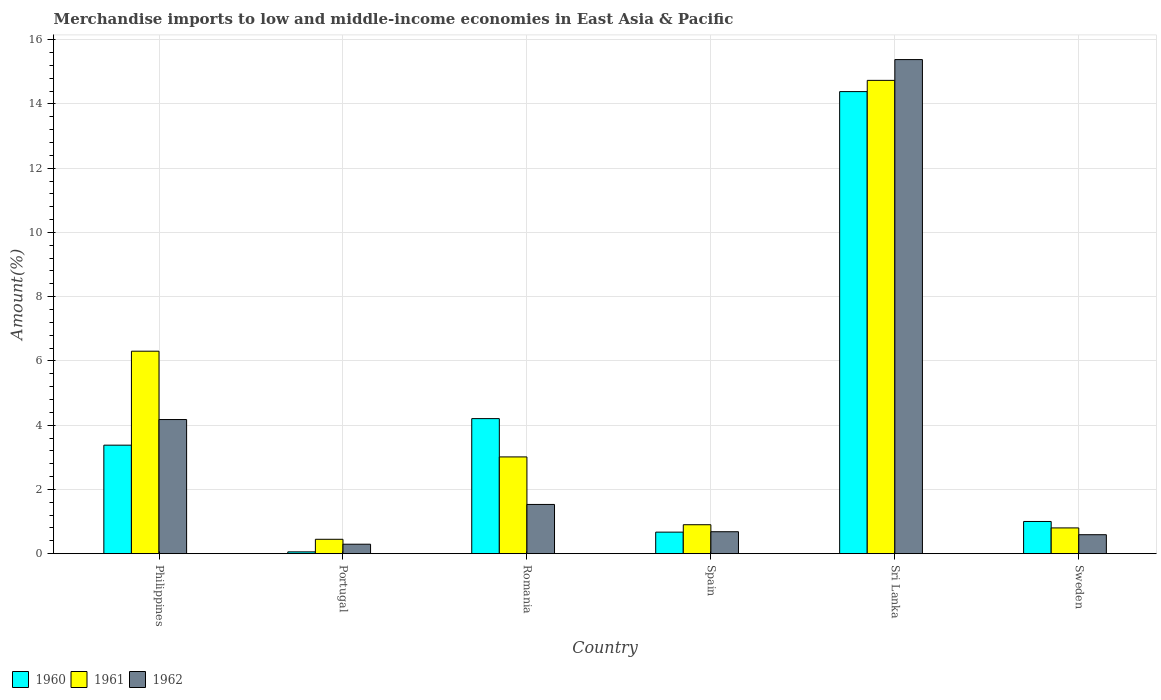How many groups of bars are there?
Provide a short and direct response. 6. Are the number of bars per tick equal to the number of legend labels?
Your answer should be compact. Yes. Are the number of bars on each tick of the X-axis equal?
Provide a short and direct response. Yes. How many bars are there on the 3rd tick from the right?
Your answer should be very brief. 3. What is the percentage of amount earned from merchandise imports in 1960 in Philippines?
Offer a terse response. 3.38. Across all countries, what is the maximum percentage of amount earned from merchandise imports in 1960?
Keep it short and to the point. 14.38. Across all countries, what is the minimum percentage of amount earned from merchandise imports in 1962?
Give a very brief answer. 0.29. In which country was the percentage of amount earned from merchandise imports in 1962 maximum?
Offer a very short reply. Sri Lanka. What is the total percentage of amount earned from merchandise imports in 1961 in the graph?
Keep it short and to the point. 26.2. What is the difference between the percentage of amount earned from merchandise imports in 1961 in Spain and that in Sweden?
Provide a succinct answer. 0.1. What is the difference between the percentage of amount earned from merchandise imports in 1960 in Sri Lanka and the percentage of amount earned from merchandise imports in 1962 in Philippines?
Make the answer very short. 10.21. What is the average percentage of amount earned from merchandise imports in 1960 per country?
Offer a terse response. 3.95. What is the difference between the percentage of amount earned from merchandise imports of/in 1961 and percentage of amount earned from merchandise imports of/in 1962 in Philippines?
Keep it short and to the point. 2.13. What is the ratio of the percentage of amount earned from merchandise imports in 1962 in Philippines to that in Portugal?
Ensure brevity in your answer.  14.2. Is the percentage of amount earned from merchandise imports in 1961 in Spain less than that in Sweden?
Provide a short and direct response. No. Is the difference between the percentage of amount earned from merchandise imports in 1961 in Romania and Sweden greater than the difference between the percentage of amount earned from merchandise imports in 1962 in Romania and Sweden?
Your response must be concise. Yes. What is the difference between the highest and the second highest percentage of amount earned from merchandise imports in 1960?
Offer a very short reply. -0.83. What is the difference between the highest and the lowest percentage of amount earned from merchandise imports in 1962?
Make the answer very short. 15.09. In how many countries, is the percentage of amount earned from merchandise imports in 1962 greater than the average percentage of amount earned from merchandise imports in 1962 taken over all countries?
Offer a terse response. 2. Is the sum of the percentage of amount earned from merchandise imports in 1962 in Romania and Sri Lanka greater than the maximum percentage of amount earned from merchandise imports in 1961 across all countries?
Give a very brief answer. Yes. What does the 3rd bar from the left in Sri Lanka represents?
Offer a very short reply. 1962. Is it the case that in every country, the sum of the percentage of amount earned from merchandise imports in 1961 and percentage of amount earned from merchandise imports in 1962 is greater than the percentage of amount earned from merchandise imports in 1960?
Your answer should be very brief. Yes. Are the values on the major ticks of Y-axis written in scientific E-notation?
Offer a very short reply. No. Does the graph contain any zero values?
Give a very brief answer. No. Where does the legend appear in the graph?
Your response must be concise. Bottom left. How many legend labels are there?
Offer a very short reply. 3. How are the legend labels stacked?
Your answer should be very brief. Horizontal. What is the title of the graph?
Your answer should be very brief. Merchandise imports to low and middle-income economies in East Asia & Pacific. Does "1979" appear as one of the legend labels in the graph?
Offer a very short reply. No. What is the label or title of the X-axis?
Give a very brief answer. Country. What is the label or title of the Y-axis?
Your answer should be very brief. Amount(%). What is the Amount(%) in 1960 in Philippines?
Ensure brevity in your answer.  3.38. What is the Amount(%) in 1961 in Philippines?
Keep it short and to the point. 6.3. What is the Amount(%) in 1962 in Philippines?
Your answer should be very brief. 4.18. What is the Amount(%) in 1960 in Portugal?
Offer a terse response. 0.06. What is the Amount(%) of 1961 in Portugal?
Offer a very short reply. 0.45. What is the Amount(%) in 1962 in Portugal?
Your answer should be compact. 0.29. What is the Amount(%) in 1960 in Romania?
Offer a very short reply. 4.2. What is the Amount(%) in 1961 in Romania?
Your answer should be compact. 3.01. What is the Amount(%) of 1962 in Romania?
Provide a short and direct response. 1.53. What is the Amount(%) in 1960 in Spain?
Keep it short and to the point. 0.67. What is the Amount(%) in 1961 in Spain?
Offer a very short reply. 0.9. What is the Amount(%) in 1962 in Spain?
Offer a very short reply. 0.68. What is the Amount(%) of 1960 in Sri Lanka?
Offer a very short reply. 14.38. What is the Amount(%) of 1961 in Sri Lanka?
Provide a succinct answer. 14.73. What is the Amount(%) in 1962 in Sri Lanka?
Keep it short and to the point. 15.38. What is the Amount(%) of 1960 in Sweden?
Offer a very short reply. 1. What is the Amount(%) in 1961 in Sweden?
Your answer should be compact. 0.8. What is the Amount(%) in 1962 in Sweden?
Provide a succinct answer. 0.59. Across all countries, what is the maximum Amount(%) in 1960?
Keep it short and to the point. 14.38. Across all countries, what is the maximum Amount(%) of 1961?
Offer a terse response. 14.73. Across all countries, what is the maximum Amount(%) of 1962?
Make the answer very short. 15.38. Across all countries, what is the minimum Amount(%) of 1960?
Offer a very short reply. 0.06. Across all countries, what is the minimum Amount(%) in 1961?
Provide a short and direct response. 0.45. Across all countries, what is the minimum Amount(%) of 1962?
Ensure brevity in your answer.  0.29. What is the total Amount(%) in 1960 in the graph?
Make the answer very short. 23.69. What is the total Amount(%) in 1961 in the graph?
Keep it short and to the point. 26.2. What is the total Amount(%) in 1962 in the graph?
Offer a terse response. 22.65. What is the difference between the Amount(%) of 1960 in Philippines and that in Portugal?
Ensure brevity in your answer.  3.32. What is the difference between the Amount(%) of 1961 in Philippines and that in Portugal?
Make the answer very short. 5.86. What is the difference between the Amount(%) of 1962 in Philippines and that in Portugal?
Ensure brevity in your answer.  3.88. What is the difference between the Amount(%) in 1960 in Philippines and that in Romania?
Your response must be concise. -0.83. What is the difference between the Amount(%) in 1961 in Philippines and that in Romania?
Your response must be concise. 3.29. What is the difference between the Amount(%) in 1962 in Philippines and that in Romania?
Keep it short and to the point. 2.64. What is the difference between the Amount(%) of 1960 in Philippines and that in Spain?
Ensure brevity in your answer.  2.71. What is the difference between the Amount(%) of 1961 in Philippines and that in Spain?
Your response must be concise. 5.4. What is the difference between the Amount(%) of 1962 in Philippines and that in Spain?
Provide a succinct answer. 3.49. What is the difference between the Amount(%) of 1960 in Philippines and that in Sri Lanka?
Make the answer very short. -11.01. What is the difference between the Amount(%) in 1961 in Philippines and that in Sri Lanka?
Offer a terse response. -8.43. What is the difference between the Amount(%) of 1962 in Philippines and that in Sri Lanka?
Your answer should be compact. -11.21. What is the difference between the Amount(%) in 1960 in Philippines and that in Sweden?
Keep it short and to the point. 2.38. What is the difference between the Amount(%) of 1961 in Philippines and that in Sweden?
Give a very brief answer. 5.5. What is the difference between the Amount(%) of 1962 in Philippines and that in Sweden?
Offer a very short reply. 3.58. What is the difference between the Amount(%) of 1960 in Portugal and that in Romania?
Your answer should be compact. -4.15. What is the difference between the Amount(%) in 1961 in Portugal and that in Romania?
Your answer should be very brief. -2.56. What is the difference between the Amount(%) in 1962 in Portugal and that in Romania?
Provide a succinct answer. -1.24. What is the difference between the Amount(%) in 1960 in Portugal and that in Spain?
Offer a terse response. -0.61. What is the difference between the Amount(%) of 1961 in Portugal and that in Spain?
Give a very brief answer. -0.45. What is the difference between the Amount(%) of 1962 in Portugal and that in Spain?
Offer a very short reply. -0.39. What is the difference between the Amount(%) of 1960 in Portugal and that in Sri Lanka?
Make the answer very short. -14.33. What is the difference between the Amount(%) in 1961 in Portugal and that in Sri Lanka?
Keep it short and to the point. -14.29. What is the difference between the Amount(%) in 1962 in Portugal and that in Sri Lanka?
Make the answer very short. -15.09. What is the difference between the Amount(%) of 1960 in Portugal and that in Sweden?
Your answer should be very brief. -0.95. What is the difference between the Amount(%) of 1961 in Portugal and that in Sweden?
Provide a succinct answer. -0.35. What is the difference between the Amount(%) of 1962 in Portugal and that in Sweden?
Provide a short and direct response. -0.3. What is the difference between the Amount(%) of 1960 in Romania and that in Spain?
Your answer should be very brief. 3.53. What is the difference between the Amount(%) in 1961 in Romania and that in Spain?
Keep it short and to the point. 2.11. What is the difference between the Amount(%) in 1962 in Romania and that in Spain?
Give a very brief answer. 0.85. What is the difference between the Amount(%) in 1960 in Romania and that in Sri Lanka?
Offer a terse response. -10.18. What is the difference between the Amount(%) of 1961 in Romania and that in Sri Lanka?
Your answer should be compact. -11.72. What is the difference between the Amount(%) of 1962 in Romania and that in Sri Lanka?
Provide a succinct answer. -13.85. What is the difference between the Amount(%) in 1960 in Romania and that in Sweden?
Give a very brief answer. 3.2. What is the difference between the Amount(%) of 1961 in Romania and that in Sweden?
Give a very brief answer. 2.21. What is the difference between the Amount(%) in 1962 in Romania and that in Sweden?
Provide a succinct answer. 0.94. What is the difference between the Amount(%) in 1960 in Spain and that in Sri Lanka?
Keep it short and to the point. -13.71. What is the difference between the Amount(%) in 1961 in Spain and that in Sri Lanka?
Provide a short and direct response. -13.83. What is the difference between the Amount(%) of 1962 in Spain and that in Sri Lanka?
Your response must be concise. -14.7. What is the difference between the Amount(%) in 1960 in Spain and that in Sweden?
Your answer should be very brief. -0.33. What is the difference between the Amount(%) in 1961 in Spain and that in Sweden?
Your response must be concise. 0.1. What is the difference between the Amount(%) of 1962 in Spain and that in Sweden?
Your answer should be very brief. 0.09. What is the difference between the Amount(%) of 1960 in Sri Lanka and that in Sweden?
Make the answer very short. 13.38. What is the difference between the Amount(%) of 1961 in Sri Lanka and that in Sweden?
Give a very brief answer. 13.93. What is the difference between the Amount(%) of 1962 in Sri Lanka and that in Sweden?
Provide a succinct answer. 14.79. What is the difference between the Amount(%) of 1960 in Philippines and the Amount(%) of 1961 in Portugal?
Offer a terse response. 2.93. What is the difference between the Amount(%) of 1960 in Philippines and the Amount(%) of 1962 in Portugal?
Your response must be concise. 3.08. What is the difference between the Amount(%) of 1961 in Philippines and the Amount(%) of 1962 in Portugal?
Give a very brief answer. 6.01. What is the difference between the Amount(%) in 1960 in Philippines and the Amount(%) in 1961 in Romania?
Provide a short and direct response. 0.37. What is the difference between the Amount(%) in 1960 in Philippines and the Amount(%) in 1962 in Romania?
Give a very brief answer. 1.85. What is the difference between the Amount(%) in 1961 in Philippines and the Amount(%) in 1962 in Romania?
Keep it short and to the point. 4.77. What is the difference between the Amount(%) of 1960 in Philippines and the Amount(%) of 1961 in Spain?
Keep it short and to the point. 2.48. What is the difference between the Amount(%) in 1960 in Philippines and the Amount(%) in 1962 in Spain?
Your answer should be compact. 2.69. What is the difference between the Amount(%) in 1961 in Philippines and the Amount(%) in 1962 in Spain?
Offer a terse response. 5.62. What is the difference between the Amount(%) in 1960 in Philippines and the Amount(%) in 1961 in Sri Lanka?
Your answer should be compact. -11.36. What is the difference between the Amount(%) of 1960 in Philippines and the Amount(%) of 1962 in Sri Lanka?
Keep it short and to the point. -12. What is the difference between the Amount(%) of 1961 in Philippines and the Amount(%) of 1962 in Sri Lanka?
Offer a terse response. -9.08. What is the difference between the Amount(%) in 1960 in Philippines and the Amount(%) in 1961 in Sweden?
Keep it short and to the point. 2.58. What is the difference between the Amount(%) in 1960 in Philippines and the Amount(%) in 1962 in Sweden?
Offer a very short reply. 2.79. What is the difference between the Amount(%) of 1961 in Philippines and the Amount(%) of 1962 in Sweden?
Your answer should be compact. 5.71. What is the difference between the Amount(%) in 1960 in Portugal and the Amount(%) in 1961 in Romania?
Keep it short and to the point. -2.96. What is the difference between the Amount(%) of 1960 in Portugal and the Amount(%) of 1962 in Romania?
Keep it short and to the point. -1.48. What is the difference between the Amount(%) of 1961 in Portugal and the Amount(%) of 1962 in Romania?
Offer a very short reply. -1.08. What is the difference between the Amount(%) of 1960 in Portugal and the Amount(%) of 1961 in Spain?
Your answer should be very brief. -0.85. What is the difference between the Amount(%) of 1960 in Portugal and the Amount(%) of 1962 in Spain?
Provide a short and direct response. -0.63. What is the difference between the Amount(%) in 1961 in Portugal and the Amount(%) in 1962 in Spain?
Provide a short and direct response. -0.24. What is the difference between the Amount(%) in 1960 in Portugal and the Amount(%) in 1961 in Sri Lanka?
Offer a very short reply. -14.68. What is the difference between the Amount(%) in 1960 in Portugal and the Amount(%) in 1962 in Sri Lanka?
Make the answer very short. -15.32. What is the difference between the Amount(%) of 1961 in Portugal and the Amount(%) of 1962 in Sri Lanka?
Give a very brief answer. -14.93. What is the difference between the Amount(%) of 1960 in Portugal and the Amount(%) of 1961 in Sweden?
Keep it short and to the point. -0.75. What is the difference between the Amount(%) of 1960 in Portugal and the Amount(%) of 1962 in Sweden?
Provide a short and direct response. -0.53. What is the difference between the Amount(%) in 1961 in Portugal and the Amount(%) in 1962 in Sweden?
Ensure brevity in your answer.  -0.14. What is the difference between the Amount(%) in 1960 in Romania and the Amount(%) in 1961 in Spain?
Provide a short and direct response. 3.3. What is the difference between the Amount(%) in 1960 in Romania and the Amount(%) in 1962 in Spain?
Make the answer very short. 3.52. What is the difference between the Amount(%) in 1961 in Romania and the Amount(%) in 1962 in Spain?
Your response must be concise. 2.33. What is the difference between the Amount(%) of 1960 in Romania and the Amount(%) of 1961 in Sri Lanka?
Ensure brevity in your answer.  -10.53. What is the difference between the Amount(%) of 1960 in Romania and the Amount(%) of 1962 in Sri Lanka?
Your answer should be very brief. -11.18. What is the difference between the Amount(%) of 1961 in Romania and the Amount(%) of 1962 in Sri Lanka?
Your answer should be compact. -12.37. What is the difference between the Amount(%) in 1960 in Romania and the Amount(%) in 1961 in Sweden?
Make the answer very short. 3.4. What is the difference between the Amount(%) in 1960 in Romania and the Amount(%) in 1962 in Sweden?
Your answer should be very brief. 3.61. What is the difference between the Amount(%) of 1961 in Romania and the Amount(%) of 1962 in Sweden?
Ensure brevity in your answer.  2.42. What is the difference between the Amount(%) of 1960 in Spain and the Amount(%) of 1961 in Sri Lanka?
Provide a succinct answer. -14.06. What is the difference between the Amount(%) in 1960 in Spain and the Amount(%) in 1962 in Sri Lanka?
Keep it short and to the point. -14.71. What is the difference between the Amount(%) in 1961 in Spain and the Amount(%) in 1962 in Sri Lanka?
Keep it short and to the point. -14.48. What is the difference between the Amount(%) in 1960 in Spain and the Amount(%) in 1961 in Sweden?
Offer a very short reply. -0.13. What is the difference between the Amount(%) of 1960 in Spain and the Amount(%) of 1962 in Sweden?
Offer a very short reply. 0.08. What is the difference between the Amount(%) of 1961 in Spain and the Amount(%) of 1962 in Sweden?
Provide a short and direct response. 0.31. What is the difference between the Amount(%) of 1960 in Sri Lanka and the Amount(%) of 1961 in Sweden?
Provide a short and direct response. 13.58. What is the difference between the Amount(%) of 1960 in Sri Lanka and the Amount(%) of 1962 in Sweden?
Offer a terse response. 13.79. What is the difference between the Amount(%) in 1961 in Sri Lanka and the Amount(%) in 1962 in Sweden?
Provide a succinct answer. 14.14. What is the average Amount(%) of 1960 per country?
Your response must be concise. 3.95. What is the average Amount(%) in 1961 per country?
Your response must be concise. 4.37. What is the average Amount(%) of 1962 per country?
Make the answer very short. 3.78. What is the difference between the Amount(%) in 1960 and Amount(%) in 1961 in Philippines?
Keep it short and to the point. -2.93. What is the difference between the Amount(%) of 1960 and Amount(%) of 1962 in Philippines?
Make the answer very short. -0.8. What is the difference between the Amount(%) in 1961 and Amount(%) in 1962 in Philippines?
Give a very brief answer. 2.13. What is the difference between the Amount(%) of 1960 and Amount(%) of 1961 in Portugal?
Offer a terse response. -0.39. What is the difference between the Amount(%) of 1960 and Amount(%) of 1962 in Portugal?
Provide a succinct answer. -0.24. What is the difference between the Amount(%) in 1961 and Amount(%) in 1962 in Portugal?
Provide a succinct answer. 0.15. What is the difference between the Amount(%) in 1960 and Amount(%) in 1961 in Romania?
Your answer should be very brief. 1.19. What is the difference between the Amount(%) of 1960 and Amount(%) of 1962 in Romania?
Your answer should be compact. 2.67. What is the difference between the Amount(%) in 1961 and Amount(%) in 1962 in Romania?
Provide a succinct answer. 1.48. What is the difference between the Amount(%) of 1960 and Amount(%) of 1961 in Spain?
Your response must be concise. -0.23. What is the difference between the Amount(%) of 1960 and Amount(%) of 1962 in Spain?
Your response must be concise. -0.01. What is the difference between the Amount(%) of 1961 and Amount(%) of 1962 in Spain?
Offer a terse response. 0.22. What is the difference between the Amount(%) of 1960 and Amount(%) of 1961 in Sri Lanka?
Ensure brevity in your answer.  -0.35. What is the difference between the Amount(%) in 1960 and Amount(%) in 1962 in Sri Lanka?
Give a very brief answer. -1. What is the difference between the Amount(%) of 1961 and Amount(%) of 1962 in Sri Lanka?
Provide a short and direct response. -0.65. What is the difference between the Amount(%) in 1960 and Amount(%) in 1961 in Sweden?
Give a very brief answer. 0.2. What is the difference between the Amount(%) in 1960 and Amount(%) in 1962 in Sweden?
Keep it short and to the point. 0.41. What is the difference between the Amount(%) in 1961 and Amount(%) in 1962 in Sweden?
Offer a terse response. 0.21. What is the ratio of the Amount(%) in 1960 in Philippines to that in Portugal?
Offer a terse response. 60.74. What is the ratio of the Amount(%) in 1961 in Philippines to that in Portugal?
Keep it short and to the point. 14.09. What is the ratio of the Amount(%) in 1962 in Philippines to that in Portugal?
Offer a terse response. 14.2. What is the ratio of the Amount(%) in 1960 in Philippines to that in Romania?
Provide a short and direct response. 0.8. What is the ratio of the Amount(%) of 1961 in Philippines to that in Romania?
Your response must be concise. 2.09. What is the ratio of the Amount(%) of 1962 in Philippines to that in Romania?
Provide a short and direct response. 2.73. What is the ratio of the Amount(%) of 1960 in Philippines to that in Spain?
Ensure brevity in your answer.  5.04. What is the ratio of the Amount(%) of 1961 in Philippines to that in Spain?
Your answer should be very brief. 7. What is the ratio of the Amount(%) of 1962 in Philippines to that in Spain?
Offer a very short reply. 6.12. What is the ratio of the Amount(%) of 1960 in Philippines to that in Sri Lanka?
Your answer should be very brief. 0.23. What is the ratio of the Amount(%) in 1961 in Philippines to that in Sri Lanka?
Offer a terse response. 0.43. What is the ratio of the Amount(%) in 1962 in Philippines to that in Sri Lanka?
Ensure brevity in your answer.  0.27. What is the ratio of the Amount(%) in 1960 in Philippines to that in Sweden?
Offer a terse response. 3.37. What is the ratio of the Amount(%) of 1961 in Philippines to that in Sweden?
Provide a short and direct response. 7.86. What is the ratio of the Amount(%) of 1962 in Philippines to that in Sweden?
Give a very brief answer. 7.08. What is the ratio of the Amount(%) in 1960 in Portugal to that in Romania?
Ensure brevity in your answer.  0.01. What is the ratio of the Amount(%) in 1961 in Portugal to that in Romania?
Give a very brief answer. 0.15. What is the ratio of the Amount(%) in 1962 in Portugal to that in Romania?
Your answer should be very brief. 0.19. What is the ratio of the Amount(%) in 1960 in Portugal to that in Spain?
Your answer should be very brief. 0.08. What is the ratio of the Amount(%) of 1961 in Portugal to that in Spain?
Keep it short and to the point. 0.5. What is the ratio of the Amount(%) in 1962 in Portugal to that in Spain?
Make the answer very short. 0.43. What is the ratio of the Amount(%) in 1960 in Portugal to that in Sri Lanka?
Keep it short and to the point. 0. What is the ratio of the Amount(%) of 1961 in Portugal to that in Sri Lanka?
Provide a succinct answer. 0.03. What is the ratio of the Amount(%) in 1962 in Portugal to that in Sri Lanka?
Give a very brief answer. 0.02. What is the ratio of the Amount(%) of 1960 in Portugal to that in Sweden?
Offer a very short reply. 0.06. What is the ratio of the Amount(%) of 1961 in Portugal to that in Sweden?
Offer a terse response. 0.56. What is the ratio of the Amount(%) of 1962 in Portugal to that in Sweden?
Your answer should be very brief. 0.5. What is the ratio of the Amount(%) in 1960 in Romania to that in Spain?
Provide a short and direct response. 6.27. What is the ratio of the Amount(%) in 1961 in Romania to that in Spain?
Provide a short and direct response. 3.34. What is the ratio of the Amount(%) in 1962 in Romania to that in Spain?
Keep it short and to the point. 2.24. What is the ratio of the Amount(%) of 1960 in Romania to that in Sri Lanka?
Provide a succinct answer. 0.29. What is the ratio of the Amount(%) in 1961 in Romania to that in Sri Lanka?
Provide a succinct answer. 0.2. What is the ratio of the Amount(%) in 1962 in Romania to that in Sri Lanka?
Your answer should be compact. 0.1. What is the ratio of the Amount(%) of 1960 in Romania to that in Sweden?
Make the answer very short. 4.2. What is the ratio of the Amount(%) of 1961 in Romania to that in Sweden?
Keep it short and to the point. 3.76. What is the ratio of the Amount(%) in 1962 in Romania to that in Sweden?
Provide a short and direct response. 2.6. What is the ratio of the Amount(%) of 1960 in Spain to that in Sri Lanka?
Keep it short and to the point. 0.05. What is the ratio of the Amount(%) of 1961 in Spain to that in Sri Lanka?
Give a very brief answer. 0.06. What is the ratio of the Amount(%) of 1962 in Spain to that in Sri Lanka?
Offer a terse response. 0.04. What is the ratio of the Amount(%) in 1960 in Spain to that in Sweden?
Your answer should be very brief. 0.67. What is the ratio of the Amount(%) of 1961 in Spain to that in Sweden?
Give a very brief answer. 1.12. What is the ratio of the Amount(%) of 1962 in Spain to that in Sweden?
Give a very brief answer. 1.16. What is the ratio of the Amount(%) of 1960 in Sri Lanka to that in Sweden?
Give a very brief answer. 14.36. What is the ratio of the Amount(%) of 1961 in Sri Lanka to that in Sweden?
Ensure brevity in your answer.  18.38. What is the ratio of the Amount(%) of 1962 in Sri Lanka to that in Sweden?
Your answer should be compact. 26.07. What is the difference between the highest and the second highest Amount(%) of 1960?
Ensure brevity in your answer.  10.18. What is the difference between the highest and the second highest Amount(%) of 1961?
Your response must be concise. 8.43. What is the difference between the highest and the second highest Amount(%) in 1962?
Keep it short and to the point. 11.21. What is the difference between the highest and the lowest Amount(%) of 1960?
Offer a very short reply. 14.33. What is the difference between the highest and the lowest Amount(%) in 1961?
Give a very brief answer. 14.29. What is the difference between the highest and the lowest Amount(%) in 1962?
Your response must be concise. 15.09. 